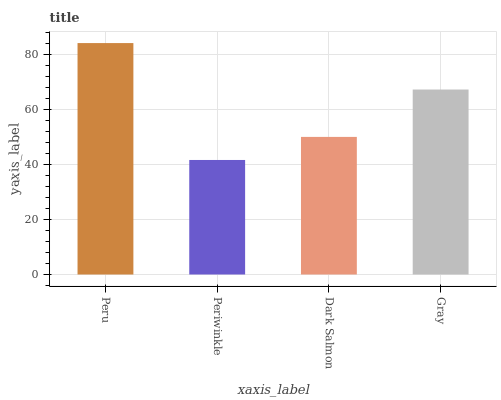Is Periwinkle the minimum?
Answer yes or no. Yes. Is Peru the maximum?
Answer yes or no. Yes. Is Dark Salmon the minimum?
Answer yes or no. No. Is Dark Salmon the maximum?
Answer yes or no. No. Is Dark Salmon greater than Periwinkle?
Answer yes or no. Yes. Is Periwinkle less than Dark Salmon?
Answer yes or no. Yes. Is Periwinkle greater than Dark Salmon?
Answer yes or no. No. Is Dark Salmon less than Periwinkle?
Answer yes or no. No. Is Gray the high median?
Answer yes or no. Yes. Is Dark Salmon the low median?
Answer yes or no. Yes. Is Peru the high median?
Answer yes or no. No. Is Peru the low median?
Answer yes or no. No. 